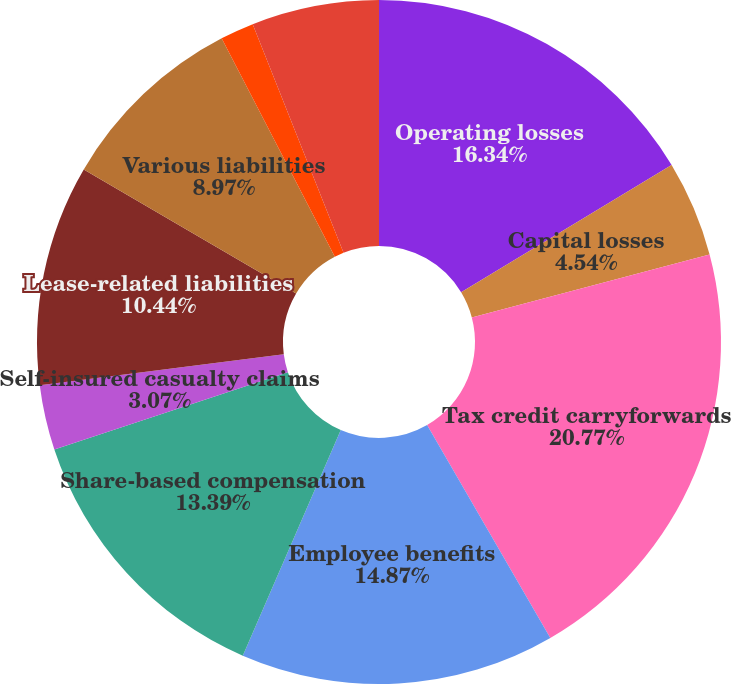Convert chart. <chart><loc_0><loc_0><loc_500><loc_500><pie_chart><fcel>Operating losses<fcel>Capital losses<fcel>Tax credit carryforwards<fcel>Employee benefits<fcel>Share-based compensation<fcel>Self-insured casualty claims<fcel>Lease-related liabilities<fcel>Various liabilities<fcel>Property plant and equipment<fcel>Deferred income and other<nl><fcel>16.34%<fcel>4.54%<fcel>20.77%<fcel>14.87%<fcel>13.39%<fcel>3.07%<fcel>10.44%<fcel>8.97%<fcel>1.59%<fcel>6.02%<nl></chart> 